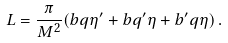Convert formula to latex. <formula><loc_0><loc_0><loc_500><loc_500>L = \frac { \pi } { M ^ { 2 } } ( b q \eta ^ { \prime } + b q ^ { \prime } \eta + b ^ { \prime } q \eta ) \, .</formula> 